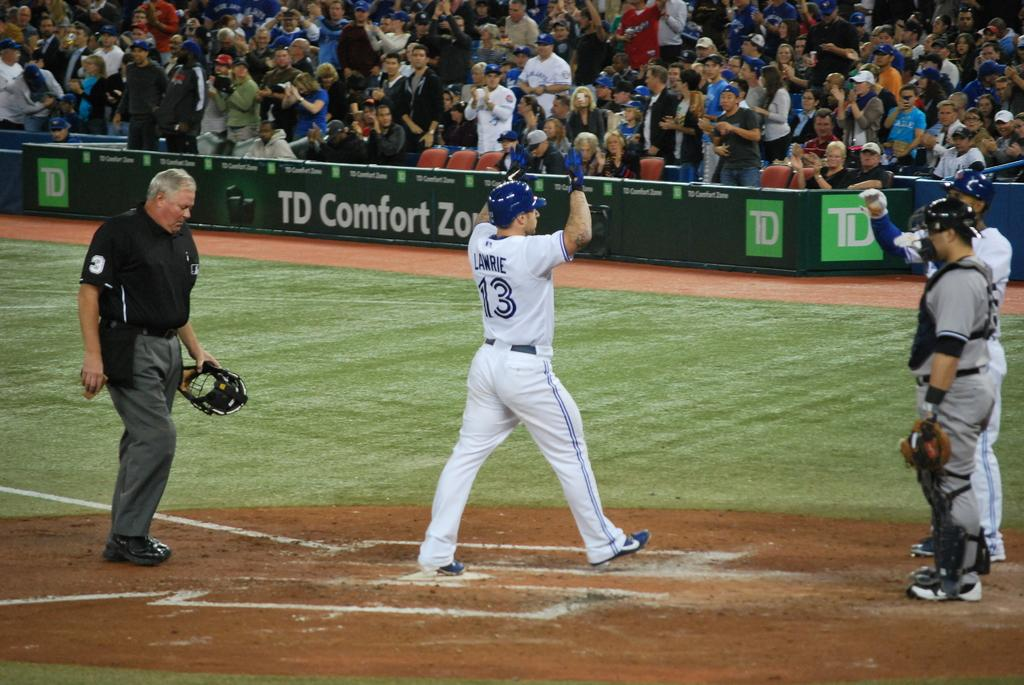Provide a one-sentence caption for the provided image. Baseball pitcher Lawrie standing near two other players during a game. 